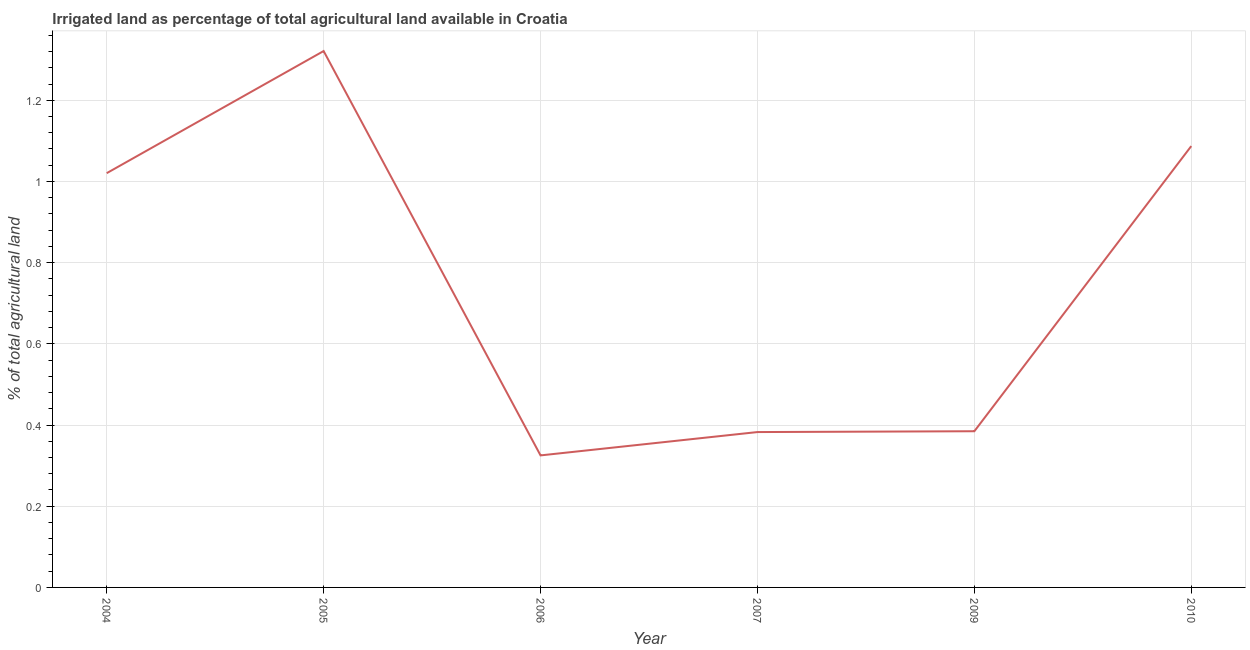What is the percentage of agricultural irrigated land in 2007?
Keep it short and to the point. 0.38. Across all years, what is the maximum percentage of agricultural irrigated land?
Offer a terse response. 1.32. Across all years, what is the minimum percentage of agricultural irrigated land?
Give a very brief answer. 0.33. In which year was the percentage of agricultural irrigated land maximum?
Offer a very short reply. 2005. In which year was the percentage of agricultural irrigated land minimum?
Provide a succinct answer. 2006. What is the sum of the percentage of agricultural irrigated land?
Offer a very short reply. 4.52. What is the difference between the percentage of agricultural irrigated land in 2006 and 2007?
Keep it short and to the point. -0.06. What is the average percentage of agricultural irrigated land per year?
Offer a terse response. 0.75. What is the median percentage of agricultural irrigated land?
Your answer should be very brief. 0.7. Do a majority of the years between 2009 and 2006 (inclusive) have percentage of agricultural irrigated land greater than 0.4 %?
Give a very brief answer. No. What is the ratio of the percentage of agricultural irrigated land in 2005 to that in 2006?
Make the answer very short. 4.06. What is the difference between the highest and the second highest percentage of agricultural irrigated land?
Make the answer very short. 0.23. Is the sum of the percentage of agricultural irrigated land in 2009 and 2010 greater than the maximum percentage of agricultural irrigated land across all years?
Provide a succinct answer. Yes. What is the difference between the highest and the lowest percentage of agricultural irrigated land?
Your answer should be compact. 1. In how many years, is the percentage of agricultural irrigated land greater than the average percentage of agricultural irrigated land taken over all years?
Make the answer very short. 3. Does the percentage of agricultural irrigated land monotonically increase over the years?
Provide a short and direct response. No. How many years are there in the graph?
Your response must be concise. 6. What is the difference between two consecutive major ticks on the Y-axis?
Your answer should be very brief. 0.2. Are the values on the major ticks of Y-axis written in scientific E-notation?
Give a very brief answer. No. Does the graph contain grids?
Your answer should be very brief. Yes. What is the title of the graph?
Give a very brief answer. Irrigated land as percentage of total agricultural land available in Croatia. What is the label or title of the X-axis?
Your answer should be compact. Year. What is the label or title of the Y-axis?
Your answer should be compact. % of total agricultural land. What is the % of total agricultural land in 2004?
Make the answer very short. 1.02. What is the % of total agricultural land of 2005?
Your answer should be compact. 1.32. What is the % of total agricultural land in 2006?
Provide a succinct answer. 0.33. What is the % of total agricultural land of 2007?
Your answer should be compact. 0.38. What is the % of total agricultural land in 2009?
Give a very brief answer. 0.38. What is the % of total agricultural land in 2010?
Offer a very short reply. 1.09. What is the difference between the % of total agricultural land in 2004 and 2005?
Keep it short and to the point. -0.3. What is the difference between the % of total agricultural land in 2004 and 2006?
Offer a terse response. 0.7. What is the difference between the % of total agricultural land in 2004 and 2007?
Keep it short and to the point. 0.64. What is the difference between the % of total agricultural land in 2004 and 2009?
Ensure brevity in your answer.  0.64. What is the difference between the % of total agricultural land in 2004 and 2010?
Keep it short and to the point. -0.07. What is the difference between the % of total agricultural land in 2005 and 2006?
Your answer should be compact. 1. What is the difference between the % of total agricultural land in 2005 and 2007?
Give a very brief answer. 0.94. What is the difference between the % of total agricultural land in 2005 and 2009?
Ensure brevity in your answer.  0.94. What is the difference between the % of total agricultural land in 2005 and 2010?
Your answer should be compact. 0.23. What is the difference between the % of total agricultural land in 2006 and 2007?
Your response must be concise. -0.06. What is the difference between the % of total agricultural land in 2006 and 2009?
Give a very brief answer. -0.06. What is the difference between the % of total agricultural land in 2006 and 2010?
Offer a very short reply. -0.76. What is the difference between the % of total agricultural land in 2007 and 2009?
Provide a succinct answer. -0. What is the difference between the % of total agricultural land in 2007 and 2010?
Provide a short and direct response. -0.7. What is the difference between the % of total agricultural land in 2009 and 2010?
Your answer should be compact. -0.7. What is the ratio of the % of total agricultural land in 2004 to that in 2005?
Offer a terse response. 0.77. What is the ratio of the % of total agricultural land in 2004 to that in 2006?
Offer a very short reply. 3.14. What is the ratio of the % of total agricultural land in 2004 to that in 2007?
Keep it short and to the point. 2.67. What is the ratio of the % of total agricultural land in 2004 to that in 2009?
Give a very brief answer. 2.65. What is the ratio of the % of total agricultural land in 2004 to that in 2010?
Offer a very short reply. 0.94. What is the ratio of the % of total agricultural land in 2005 to that in 2006?
Your answer should be compact. 4.06. What is the ratio of the % of total agricultural land in 2005 to that in 2007?
Offer a very short reply. 3.45. What is the ratio of the % of total agricultural land in 2005 to that in 2009?
Your response must be concise. 3.43. What is the ratio of the % of total agricultural land in 2005 to that in 2010?
Your response must be concise. 1.22. What is the ratio of the % of total agricultural land in 2006 to that in 2007?
Offer a terse response. 0.85. What is the ratio of the % of total agricultural land in 2006 to that in 2009?
Your answer should be very brief. 0.84. What is the ratio of the % of total agricultural land in 2006 to that in 2010?
Your answer should be very brief. 0.3. What is the ratio of the % of total agricultural land in 2007 to that in 2010?
Provide a succinct answer. 0.35. What is the ratio of the % of total agricultural land in 2009 to that in 2010?
Your answer should be compact. 0.35. 